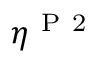Convert formula to latex. <formula><loc_0><loc_0><loc_500><loc_500>\eta ^ { P 2 }</formula> 